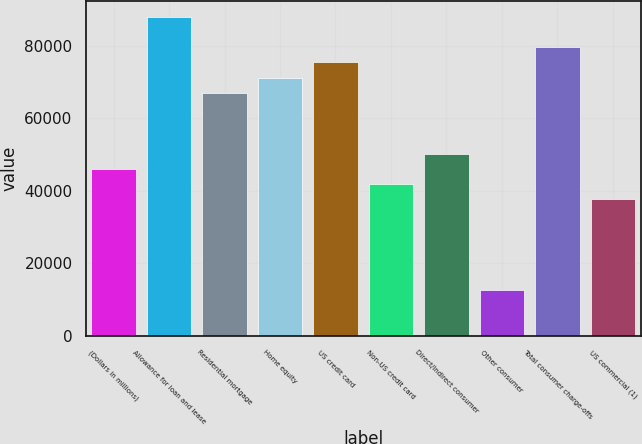<chart> <loc_0><loc_0><loc_500><loc_500><bar_chart><fcel>(Dollars in millions)<fcel>Allowance for loan and lease<fcel>Residential mortgage<fcel>Home equity<fcel>US credit card<fcel>Non-US credit card<fcel>Direct/Indirect consumer<fcel>Other consumer<fcel>Total consumer charge-offs<fcel>US commercial (1)<nl><fcel>46073.2<fcel>87955.2<fcel>67014.2<fcel>71202.4<fcel>75390.6<fcel>41885<fcel>50261.4<fcel>12567.6<fcel>79578.8<fcel>37696.8<nl></chart> 